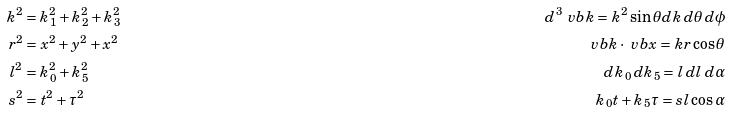<formula> <loc_0><loc_0><loc_500><loc_500>k ^ { 2 } & = k _ { 1 } ^ { 2 } + k _ { 2 } ^ { 2 } + k _ { 3 } ^ { 2 } \quad & d ^ { 3 } \ v b { k } = k ^ { 2 } \sin \theta d k \, d \theta \, d \phi \\ r ^ { 2 } & = x ^ { 2 } + y ^ { 2 } + x ^ { 2 } \quad & \ v b { k } \cdot \ v b { x } = k r \cos \theta \\ l ^ { 2 } & = k _ { 0 } ^ { 2 } + k _ { 5 } ^ { 2 } \quad & d k _ { 0 } \, d k _ { 5 } = l \, d l \, d \alpha \\ s ^ { 2 } & = t ^ { 2 } + \tau ^ { 2 } \quad & k _ { 0 } t + k _ { 5 } \tau = s l \cos \alpha \\</formula> 